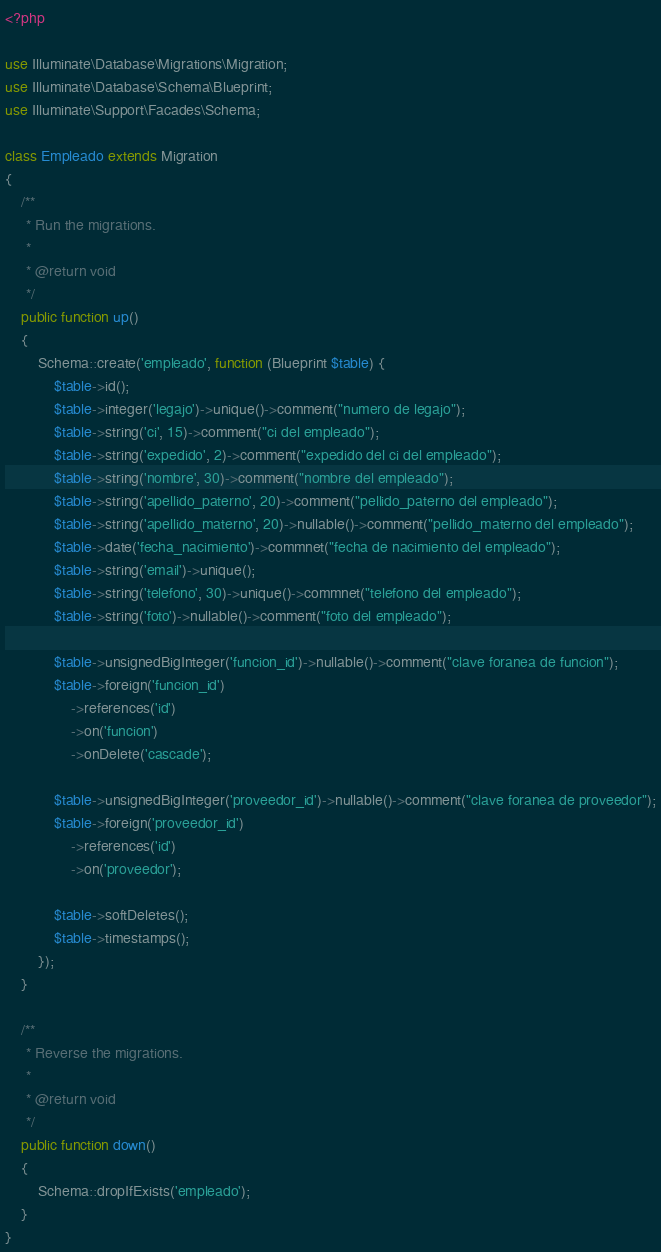<code> <loc_0><loc_0><loc_500><loc_500><_PHP_><?php

use Illuminate\Database\Migrations\Migration;
use Illuminate\Database\Schema\Blueprint;
use Illuminate\Support\Facades\Schema;

class Empleado extends Migration
{
    /**
     * Run the migrations.
     *
     * @return void
     */
    public function up()
    {
        Schema::create('empleado', function (Blueprint $table) {
            $table->id();
            $table->integer('legajo')->unique()->comment("numero de legajo");
            $table->string('ci', 15)->comment("ci del empleado");
            $table->string('expedido', 2)->comment("expedido del ci del empleado");
            $table->string('nombre', 30)->comment("nombre del empleado");
            $table->string('apellido_paterno', 20)->comment("pellido_paterno del empleado");
            $table->string('apellido_materno', 20)->nullable()->comment("pellido_materno del empleado");
            $table->date('fecha_nacimiento')->commnet("fecha de nacimiento del empleado");
            $table->string('email')->unique();
            $table->string('telefono', 30)->unique()->commnet("telefono del empleado");
            $table->string('foto')->nullable()->comment("foto del empleado");

            $table->unsignedBigInteger('funcion_id')->nullable()->comment("clave foranea de funcion");
            $table->foreign('funcion_id')
                ->references('id')
                ->on('funcion')
                ->onDelete('cascade');

            $table->unsignedBigInteger('proveedor_id')->nullable()->comment("clave foranea de proveedor");
            $table->foreign('proveedor_id')
                ->references('id')
                ->on('proveedor');

            $table->softDeletes();
            $table->timestamps();
        });
    }

    /**
     * Reverse the migrations.
     *
     * @return void
     */
    public function down()
    {
        Schema::dropIfExists('empleado');
    }
}
</code> 